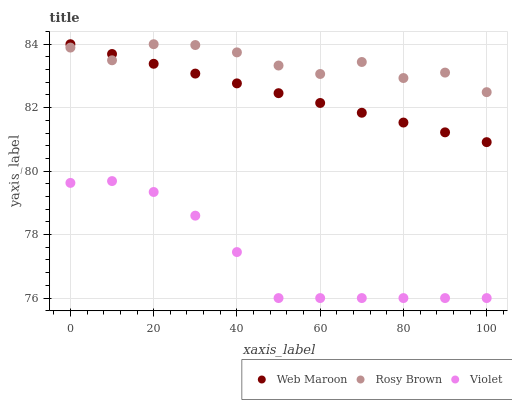Does Violet have the minimum area under the curve?
Answer yes or no. Yes. Does Rosy Brown have the maximum area under the curve?
Answer yes or no. Yes. Does Web Maroon have the minimum area under the curve?
Answer yes or no. No. Does Web Maroon have the maximum area under the curve?
Answer yes or no. No. Is Web Maroon the smoothest?
Answer yes or no. Yes. Is Rosy Brown the roughest?
Answer yes or no. Yes. Is Violet the smoothest?
Answer yes or no. No. Is Violet the roughest?
Answer yes or no. No. Does Violet have the lowest value?
Answer yes or no. Yes. Does Web Maroon have the lowest value?
Answer yes or no. No. Does Web Maroon have the highest value?
Answer yes or no. Yes. Does Violet have the highest value?
Answer yes or no. No. Is Violet less than Rosy Brown?
Answer yes or no. Yes. Is Web Maroon greater than Violet?
Answer yes or no. Yes. Does Rosy Brown intersect Web Maroon?
Answer yes or no. Yes. Is Rosy Brown less than Web Maroon?
Answer yes or no. No. Is Rosy Brown greater than Web Maroon?
Answer yes or no. No. Does Violet intersect Rosy Brown?
Answer yes or no. No. 